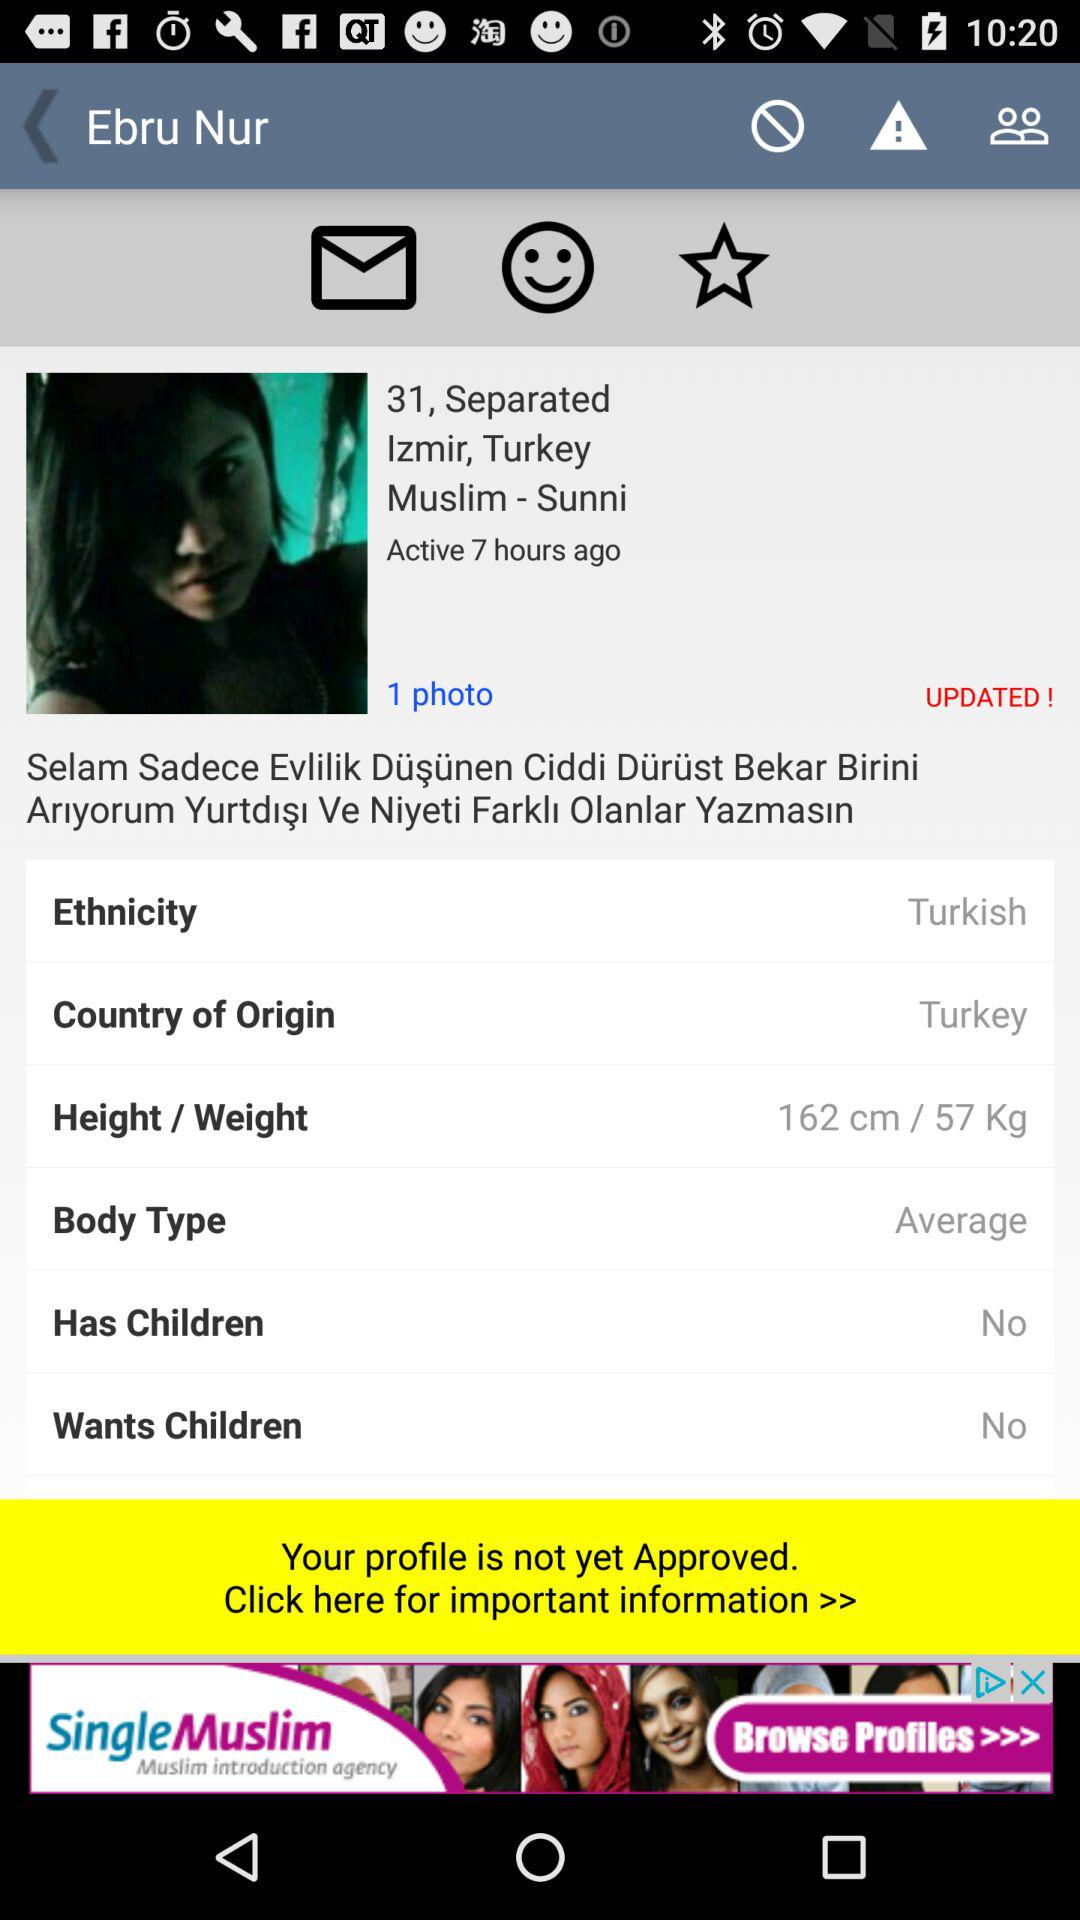What is the number of children this person has? This person has no children. 